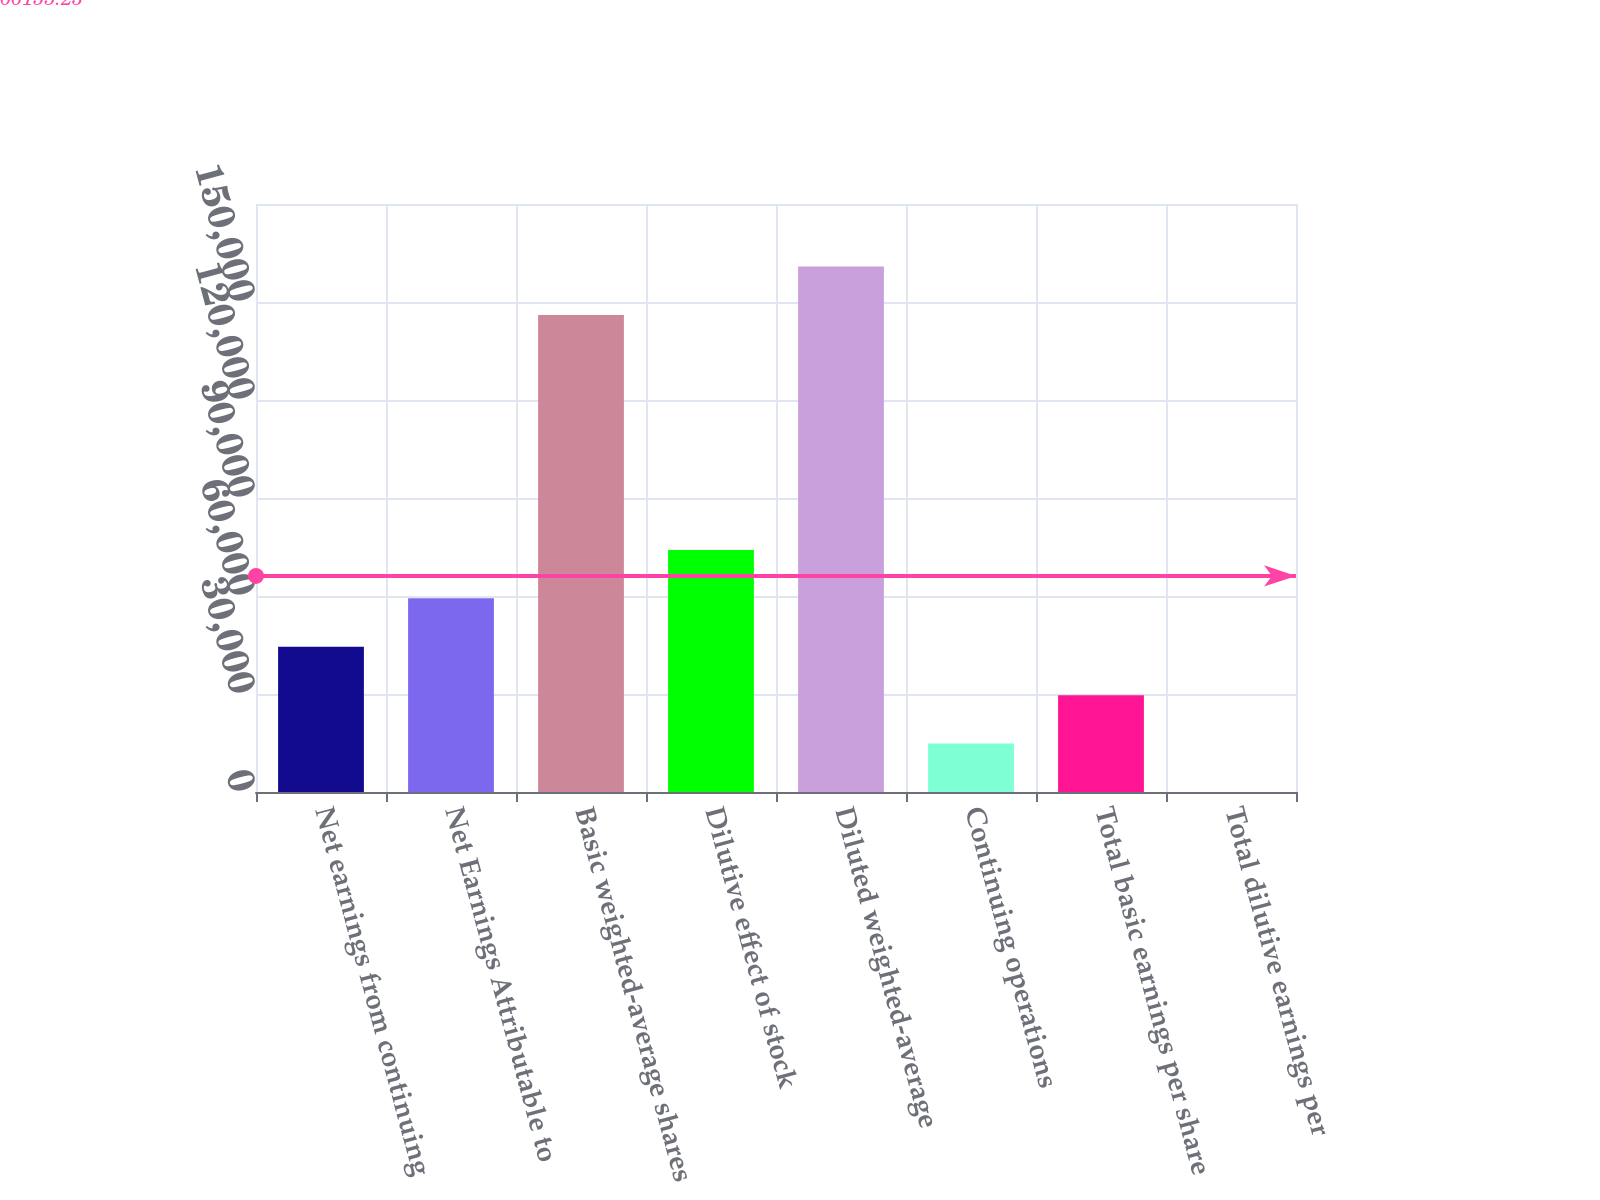Convert chart to OTSL. <chart><loc_0><loc_0><loc_500><loc_500><bar_chart><fcel>Net earnings from continuing<fcel>Net Earnings Attributable to<fcel>Basic weighted-average shares<fcel>Dilutive effect of stock<fcel>Diluted weighted-average<fcel>Continuing operations<fcel>Total basic earnings per share<fcel>Total dilutive earnings per<nl><fcel>44466.7<fcel>59286.7<fcel>146041<fcel>74106.8<fcel>160861<fcel>14826.6<fcel>29646.6<fcel>6.51<nl></chart> 